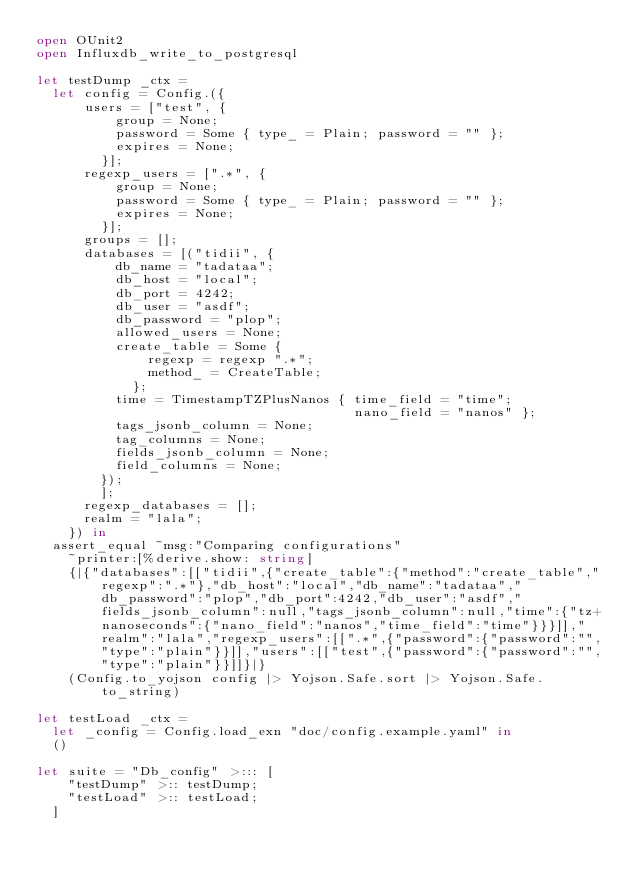Convert code to text. <code><loc_0><loc_0><loc_500><loc_500><_OCaml_>open OUnit2
open Influxdb_write_to_postgresql

let testDump _ctx =
  let config = Config.({
      users = ["test", {
          group = None;
          password = Some { type_ = Plain; password = "" };
          expires = None;
        }];
      regexp_users = [".*", {
          group = None;
          password = Some { type_ = Plain; password = "" };
          expires = None;
        }];
      groups = [];
      databases = [("tidii", {
          db_name = "tadataa";
          db_host = "local";
          db_port = 4242;
          db_user = "asdf";
          db_password = "plop";
          allowed_users = None;
          create_table = Some {
              regexp = regexp ".*";
              method_ = CreateTable;
            };
          time = TimestampTZPlusNanos { time_field = "time";
                                        nano_field = "nanos" };
          tags_jsonb_column = None;
          tag_columns = None;
          fields_jsonb_column = None;
          field_columns = None;
        });
        ];
      regexp_databases = [];
      realm = "lala";
    }) in
  assert_equal ~msg:"Comparing configurations"
    ~printer:[%derive.show: string]
    {|{"databases":[["tidii",{"create_table":{"method":"create_table","regexp":".*"},"db_host":"local","db_name":"tadataa","db_password":"plop","db_port":4242,"db_user":"asdf","fields_jsonb_column":null,"tags_jsonb_column":null,"time":{"tz+nanoseconds":{"nano_field":"nanos","time_field":"time"}}}]],"realm":"lala","regexp_users":[[".*",{"password":{"password":"","type":"plain"}}]],"users":[["test",{"password":{"password":"","type":"plain"}}]]}|}
    (Config.to_yojson config |> Yojson.Safe.sort |> Yojson.Safe.to_string)

let testLoad _ctx =
  let _config = Config.load_exn "doc/config.example.yaml" in
  ()

let suite = "Db_config" >::: [
    "testDump" >:: testDump;
    "testLoad" >:: testLoad;
  ]
</code> 